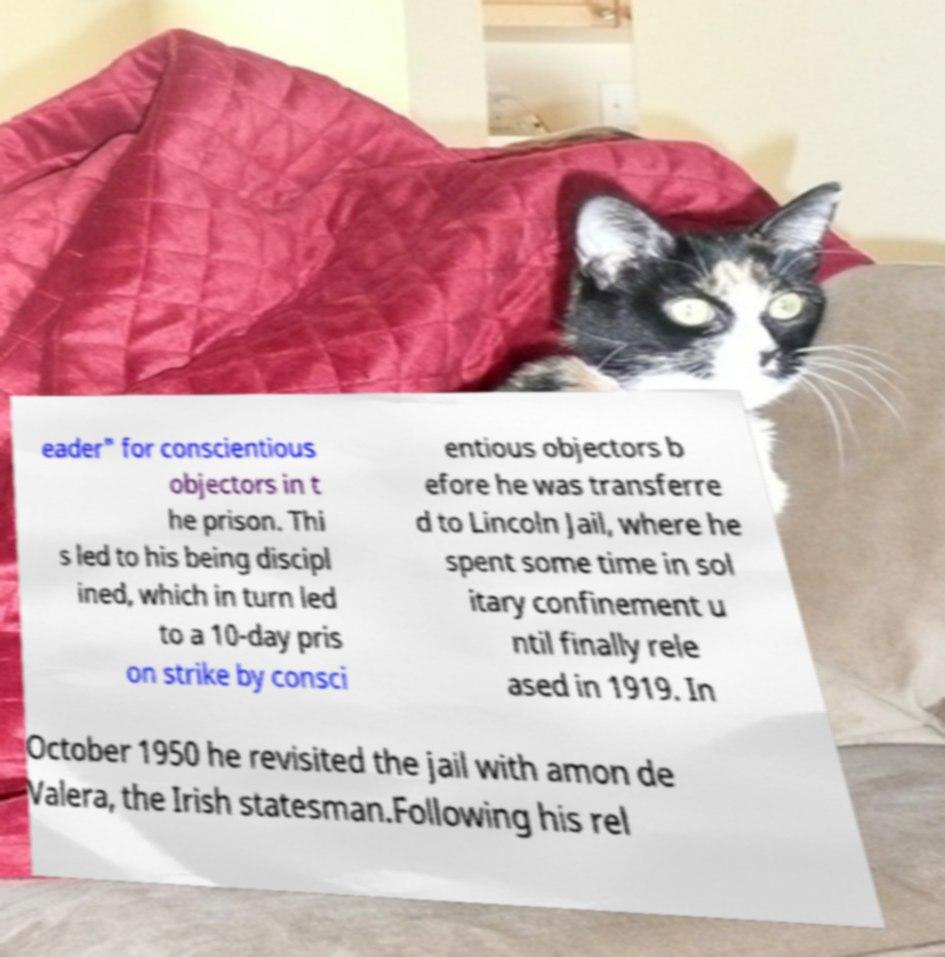I need the written content from this picture converted into text. Can you do that? eader" for conscientious objectors in t he prison. Thi s led to his being discipl ined, which in turn led to a 10-day pris on strike by consci entious objectors b efore he was transferre d to Lincoln Jail, where he spent some time in sol itary confinement u ntil finally rele ased in 1919. In October 1950 he revisited the jail with amon de Valera, the Irish statesman.Following his rel 